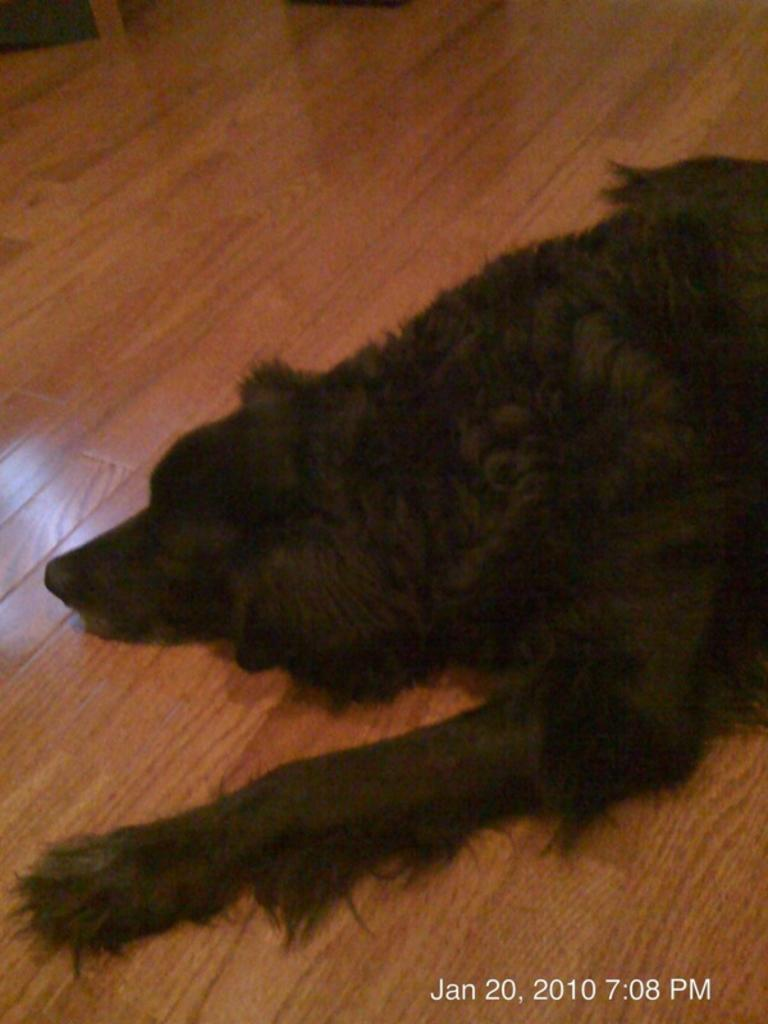What animal can be seen in the image? There is a dog in the image. What type of surface is the dog lying on? The dog is lying on a wooden floor. Can you describe the object at the top left of the image? Unfortunately, the facts provided do not give any information about the object at the top left of the image. What additional information is present at the bottom right of the image? The date and time are present at the bottom right of the image. What type of honey is being collected by the dog in the image? There is no honey or any indication of honey collection in the image; it features a dog lying on a wooden floor. What year is depicted in the image? The facts provided do not give any information about the year depicted in the image. 